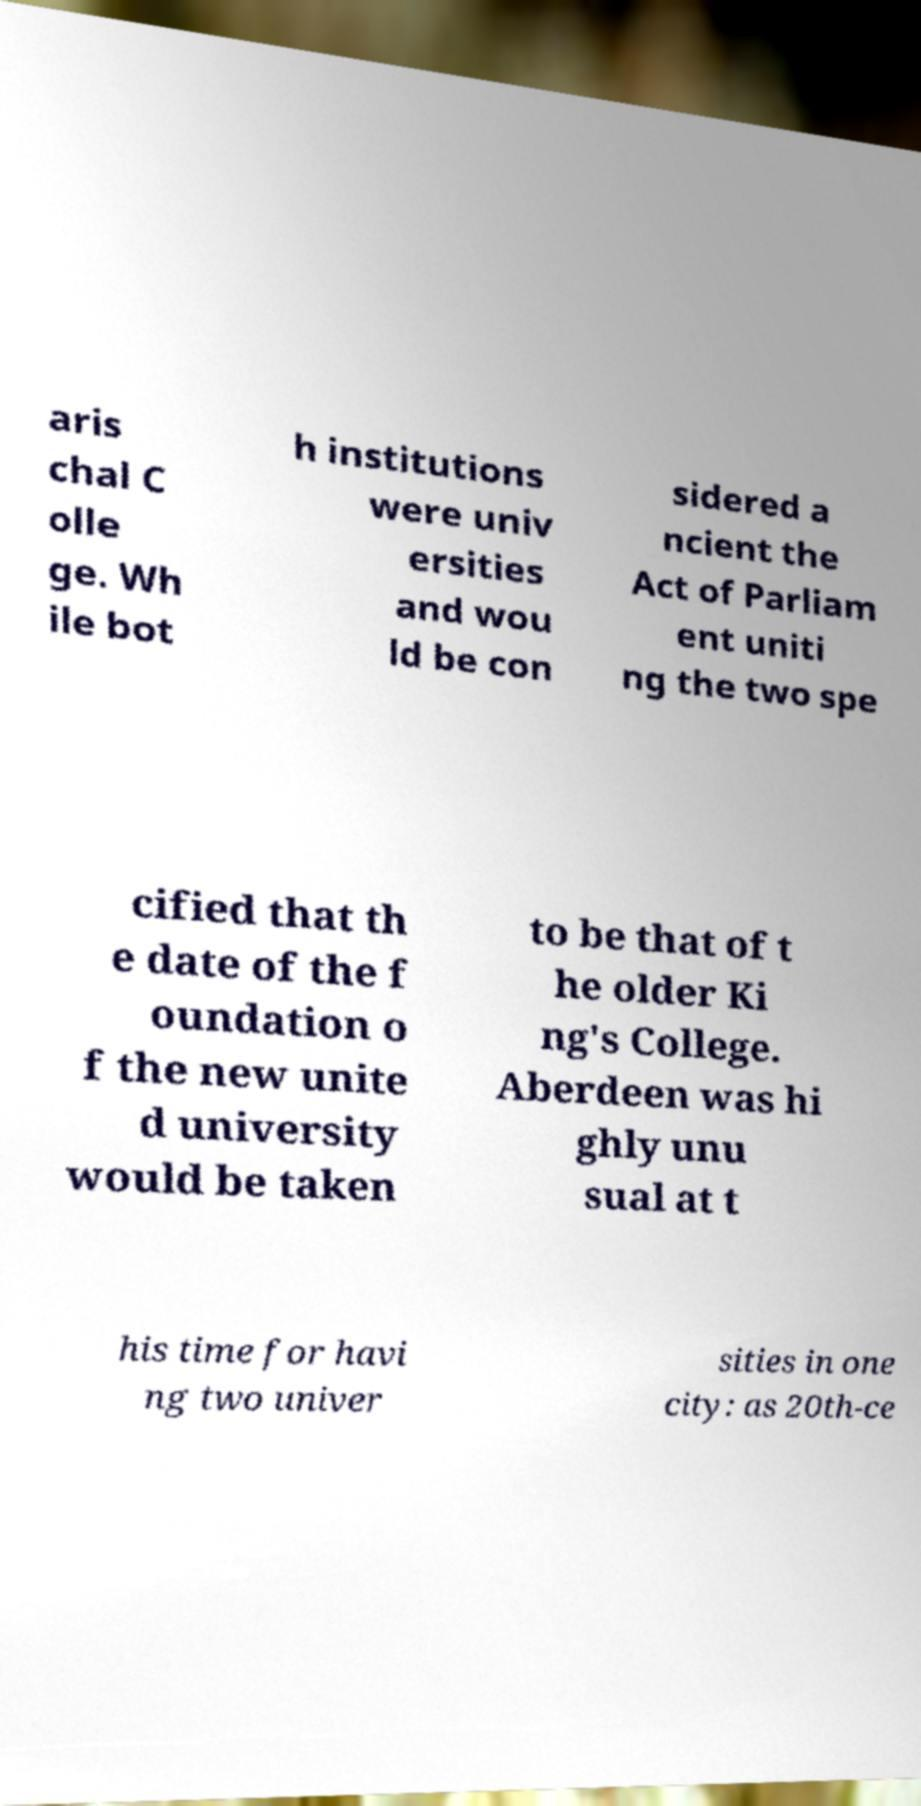There's text embedded in this image that I need extracted. Can you transcribe it verbatim? aris chal C olle ge. Wh ile bot h institutions were univ ersities and wou ld be con sidered a ncient the Act of Parliam ent uniti ng the two spe cified that th e date of the f oundation o f the new unite d university would be taken to be that of t he older Ki ng's College. Aberdeen was hi ghly unu sual at t his time for havi ng two univer sities in one city: as 20th-ce 